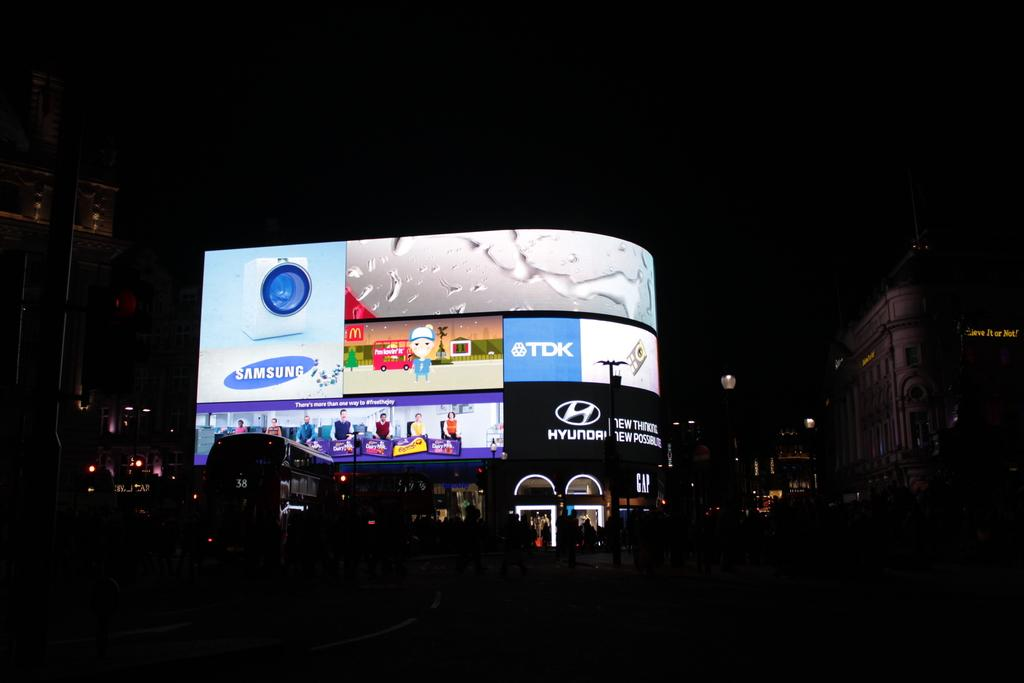<image>
Provide a brief description of the given image. An illuminated billboard with many adverts, one of which is for Samsung. 